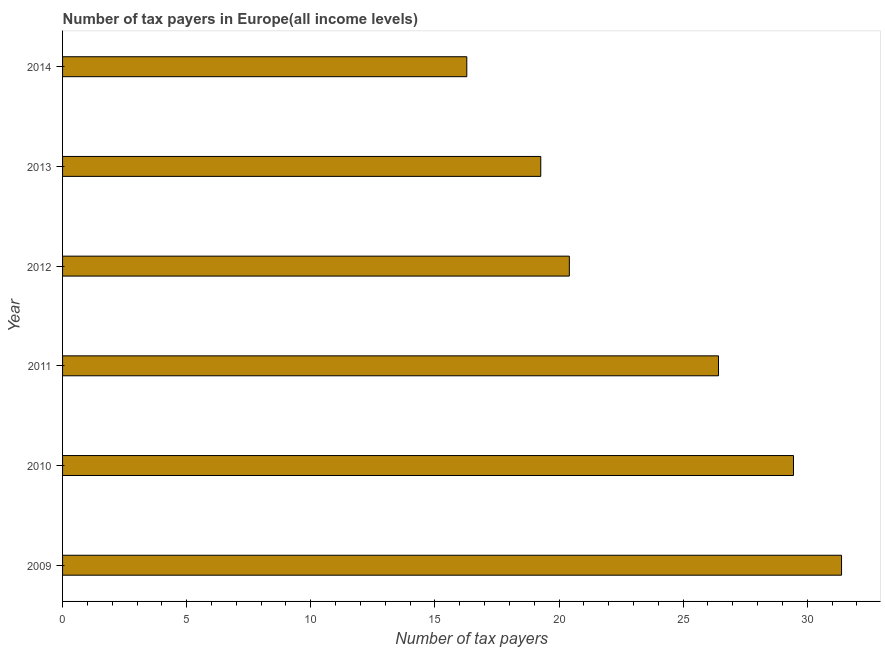Does the graph contain any zero values?
Make the answer very short. No. Does the graph contain grids?
Provide a short and direct response. No. What is the title of the graph?
Give a very brief answer. Number of tax payers in Europe(all income levels). What is the label or title of the X-axis?
Offer a very short reply. Number of tax payers. What is the label or title of the Y-axis?
Your answer should be very brief. Year. What is the number of tax payers in 2010?
Provide a short and direct response. 29.45. Across all years, what is the maximum number of tax payers?
Make the answer very short. 31.38. Across all years, what is the minimum number of tax payers?
Offer a very short reply. 16.29. In which year was the number of tax payers maximum?
Offer a terse response. 2009. What is the sum of the number of tax payers?
Provide a short and direct response. 143.22. What is the difference between the number of tax payers in 2009 and 2012?
Make the answer very short. 10.97. What is the average number of tax payers per year?
Offer a terse response. 23.87. What is the median number of tax payers?
Your answer should be very brief. 23.42. In how many years, is the number of tax payers greater than 2 ?
Provide a succinct answer. 6. Do a majority of the years between 2010 and 2012 (inclusive) have number of tax payers greater than 22 ?
Ensure brevity in your answer.  Yes. What is the ratio of the number of tax payers in 2013 to that in 2014?
Your answer should be very brief. 1.18. What is the difference between the highest and the second highest number of tax payers?
Provide a short and direct response. 1.94. What is the difference between two consecutive major ticks on the X-axis?
Your answer should be compact. 5. What is the Number of tax payers of 2009?
Provide a succinct answer. 31.38. What is the Number of tax payers of 2010?
Give a very brief answer. 29.45. What is the Number of tax payers in 2011?
Your response must be concise. 26.43. What is the Number of tax payers in 2012?
Provide a succinct answer. 20.42. What is the Number of tax payers of 2013?
Provide a short and direct response. 19.27. What is the Number of tax payers in 2014?
Your answer should be compact. 16.29. What is the difference between the Number of tax payers in 2009 and 2010?
Make the answer very short. 1.94. What is the difference between the Number of tax payers in 2009 and 2011?
Your response must be concise. 4.96. What is the difference between the Number of tax payers in 2009 and 2012?
Keep it short and to the point. 10.97. What is the difference between the Number of tax payers in 2009 and 2013?
Give a very brief answer. 12.12. What is the difference between the Number of tax payers in 2009 and 2014?
Your answer should be compact. 15.1. What is the difference between the Number of tax payers in 2010 and 2011?
Your response must be concise. 3.02. What is the difference between the Number of tax payers in 2010 and 2012?
Keep it short and to the point. 9.03. What is the difference between the Number of tax payers in 2010 and 2013?
Give a very brief answer. 10.18. What is the difference between the Number of tax payers in 2010 and 2014?
Provide a succinct answer. 13.16. What is the difference between the Number of tax payers in 2011 and 2012?
Your answer should be compact. 6.01. What is the difference between the Number of tax payers in 2011 and 2013?
Offer a very short reply. 7.16. What is the difference between the Number of tax payers in 2011 and 2014?
Your answer should be compact. 10.14. What is the difference between the Number of tax payers in 2012 and 2013?
Offer a terse response. 1.15. What is the difference between the Number of tax payers in 2012 and 2014?
Offer a very short reply. 4.13. What is the difference between the Number of tax payers in 2013 and 2014?
Offer a terse response. 2.98. What is the ratio of the Number of tax payers in 2009 to that in 2010?
Your answer should be very brief. 1.07. What is the ratio of the Number of tax payers in 2009 to that in 2011?
Keep it short and to the point. 1.19. What is the ratio of the Number of tax payers in 2009 to that in 2012?
Your answer should be compact. 1.54. What is the ratio of the Number of tax payers in 2009 to that in 2013?
Provide a succinct answer. 1.63. What is the ratio of the Number of tax payers in 2009 to that in 2014?
Make the answer very short. 1.93. What is the ratio of the Number of tax payers in 2010 to that in 2011?
Your answer should be compact. 1.11. What is the ratio of the Number of tax payers in 2010 to that in 2012?
Offer a very short reply. 1.44. What is the ratio of the Number of tax payers in 2010 to that in 2013?
Offer a terse response. 1.53. What is the ratio of the Number of tax payers in 2010 to that in 2014?
Provide a succinct answer. 1.81. What is the ratio of the Number of tax payers in 2011 to that in 2012?
Make the answer very short. 1.29. What is the ratio of the Number of tax payers in 2011 to that in 2013?
Offer a very short reply. 1.37. What is the ratio of the Number of tax payers in 2011 to that in 2014?
Your response must be concise. 1.62. What is the ratio of the Number of tax payers in 2012 to that in 2013?
Your answer should be very brief. 1.06. What is the ratio of the Number of tax payers in 2012 to that in 2014?
Keep it short and to the point. 1.25. What is the ratio of the Number of tax payers in 2013 to that in 2014?
Your answer should be very brief. 1.18. 